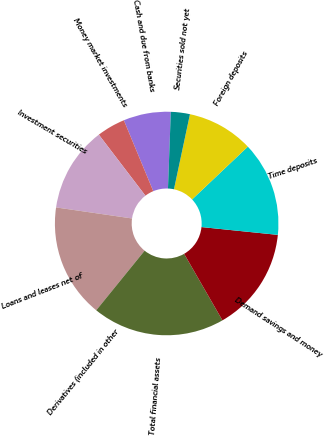Convert chart to OTSL. <chart><loc_0><loc_0><loc_500><loc_500><pie_chart><fcel>Cash and due from banks<fcel>Money market investments<fcel>Investment securities<fcel>Loans and leases net of<fcel>Derivatives (included in other<fcel>Total financial assets<fcel>Demand savings and money<fcel>Time deposits<fcel>Foreign deposits<fcel>Securities sold not yet<nl><fcel>6.85%<fcel>4.12%<fcel>12.32%<fcel>16.43%<fcel>0.02%<fcel>19.16%<fcel>15.06%<fcel>13.69%<fcel>9.59%<fcel>2.75%<nl></chart> 